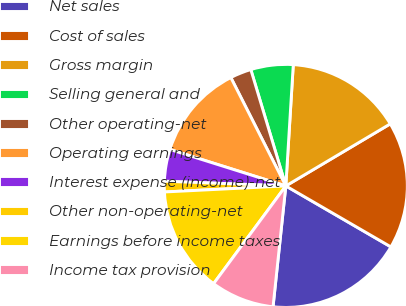<chart> <loc_0><loc_0><loc_500><loc_500><pie_chart><fcel>Net sales<fcel>Cost of sales<fcel>Gross margin<fcel>Selling general and<fcel>Other operating-net<fcel>Operating earnings<fcel>Interest expense (income)-net<fcel>Other non-operating-net<fcel>Earnings before income taxes<fcel>Income tax provision<nl><fcel>18.31%<fcel>16.9%<fcel>15.49%<fcel>5.63%<fcel>2.82%<fcel>12.68%<fcel>4.23%<fcel>1.41%<fcel>14.08%<fcel>8.45%<nl></chart> 